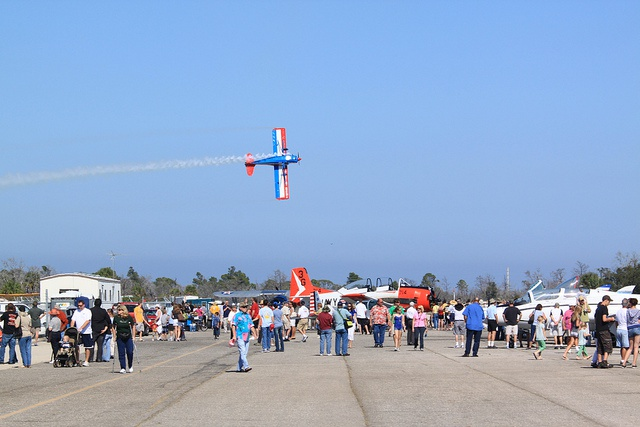Describe the objects in this image and their specific colors. I can see people in lightblue, darkgray, lightgray, gray, and black tones, airplane in lightblue, white, salmon, gray, and black tones, airplane in lightblue, white, darkgray, and gray tones, airplane in lightblue, white, and salmon tones, and people in lightblue, black, navy, gray, and tan tones in this image. 